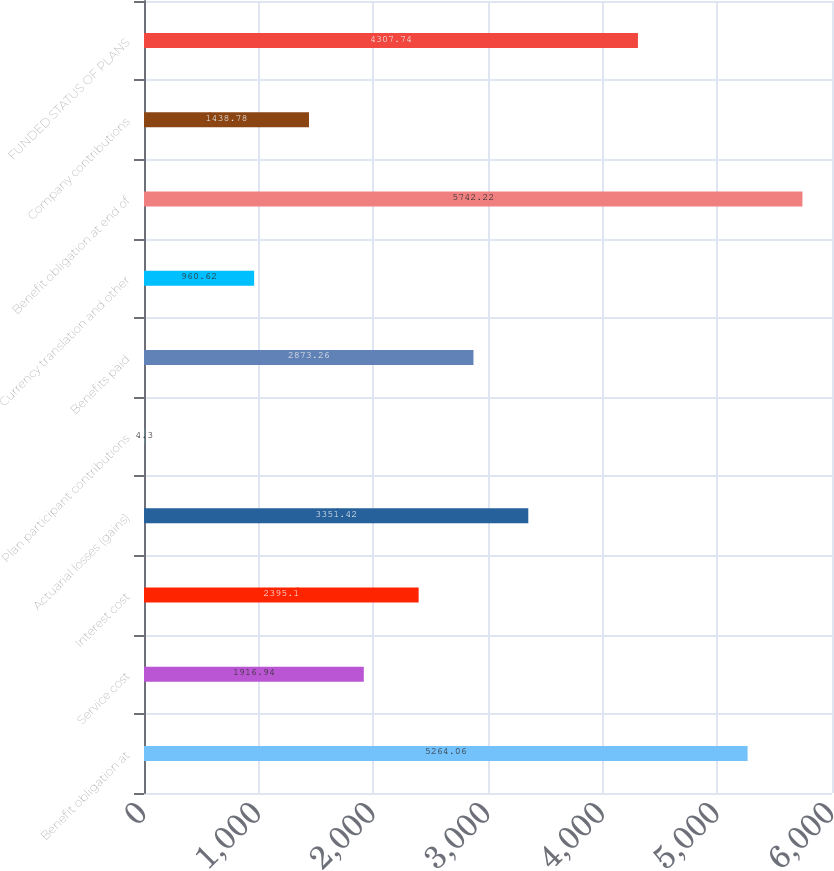Convert chart. <chart><loc_0><loc_0><loc_500><loc_500><bar_chart><fcel>Benefit obligation at<fcel>Service cost<fcel>Interest cost<fcel>Actuarial losses (gains)<fcel>Plan participant contributions<fcel>Benefits paid<fcel>Currency translation and other<fcel>Benefit obligation at end of<fcel>Company contributions<fcel>FUNDED STATUS OF PLANS<nl><fcel>5264.06<fcel>1916.94<fcel>2395.1<fcel>3351.42<fcel>4.3<fcel>2873.26<fcel>960.62<fcel>5742.22<fcel>1438.78<fcel>4307.74<nl></chart> 